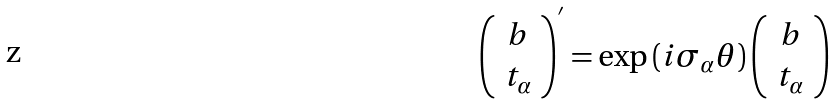Convert formula to latex. <formula><loc_0><loc_0><loc_500><loc_500>\left ( \begin{array} { c } b \\ t _ { \alpha } \end{array} \right ) ^ { ^ { \prime } } = \exp \left ( i \sigma _ { \alpha } \theta \right ) \left ( \begin{array} { c } b \\ t _ { \alpha } \end{array} \right )</formula> 